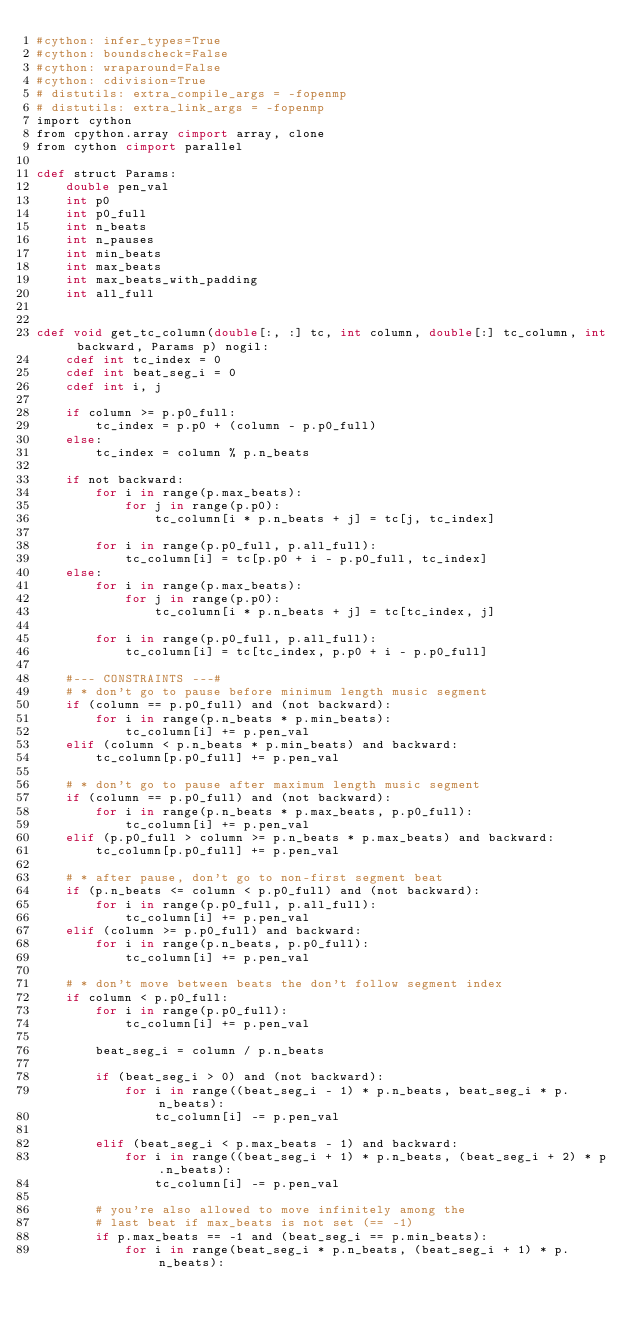<code> <loc_0><loc_0><loc_500><loc_500><_Cython_>#cython: infer_types=True
#cython: boundscheck=False
#cython: wraparound=False
#cython: cdivision=True
# distutils: extra_compile_args = -fopenmp
# distutils: extra_link_args = -fopenmp
import cython
from cpython.array cimport array, clone
from cython cimport parallel

cdef struct Params:
    double pen_val
    int p0
    int p0_full
    int n_beats
    int n_pauses
    int min_beats
    int max_beats
    int max_beats_with_padding
    int all_full


cdef void get_tc_column(double[:, :] tc, int column, double[:] tc_column, int backward, Params p) nogil:
    cdef int tc_index = 0
    cdef int beat_seg_i = 0
    cdef int i, j

    if column >= p.p0_full:
        tc_index = p.p0 + (column - p.p0_full)
    else:
        tc_index = column % p.n_beats

    if not backward:
        for i in range(p.max_beats):
            for j in range(p.p0):
                tc_column[i * p.n_beats + j] = tc[j, tc_index]

        for i in range(p.p0_full, p.all_full):
            tc_column[i] = tc[p.p0 + i - p.p0_full, tc_index]
    else:
        for i in range(p.max_beats):
            for j in range(p.p0):
                tc_column[i * p.n_beats + j] = tc[tc_index, j]

        for i in range(p.p0_full, p.all_full):
            tc_column[i] = tc[tc_index, p.p0 + i - p.p0_full]

    #--- CONSTRAINTS ---#
    # * don't go to pause before minimum length music segment
    if (column == p.p0_full) and (not backward):
        for i in range(p.n_beats * p.min_beats):
            tc_column[i] += p.pen_val
    elif (column < p.n_beats * p.min_beats) and backward:
        tc_column[p.p0_full] += p.pen_val

    # * don't go to pause after maximum length music segment
    if (column == p.p0_full) and (not backward):
        for i in range(p.n_beats * p.max_beats, p.p0_full):
            tc_column[i] += p.pen_val
    elif (p.p0_full > column >= p.n_beats * p.max_beats) and backward:
        tc_column[p.p0_full] += p.pen_val

    # * after pause, don't go to non-first segment beat
    if (p.n_beats <= column < p.p0_full) and (not backward):
        for i in range(p.p0_full, p.all_full):
            tc_column[i] += p.pen_val
    elif (column >= p.p0_full) and backward:
        for i in range(p.n_beats, p.p0_full):
            tc_column[i] += p.pen_val

    # * don't move between beats the don't follow segment index
    if column < p.p0_full:
        for i in range(p.p0_full):
            tc_column[i] += p.pen_val

        beat_seg_i = column / p.n_beats

        if (beat_seg_i > 0) and (not backward):
            for i in range((beat_seg_i - 1) * p.n_beats, beat_seg_i * p.n_beats):
                tc_column[i] -= p.pen_val

        elif (beat_seg_i < p.max_beats - 1) and backward:
            for i in range((beat_seg_i + 1) * p.n_beats, (beat_seg_i + 2) * p.n_beats):
                tc_column[i] -= p.pen_val

        # you're also allowed to move infinitely among the
        # last beat if max_beats is not set (== -1)
        if p.max_beats == -1 and (beat_seg_i == p.min_beats):
            for i in range(beat_seg_i * p.n_beats, (beat_seg_i + 1) * p.n_beats):</code> 